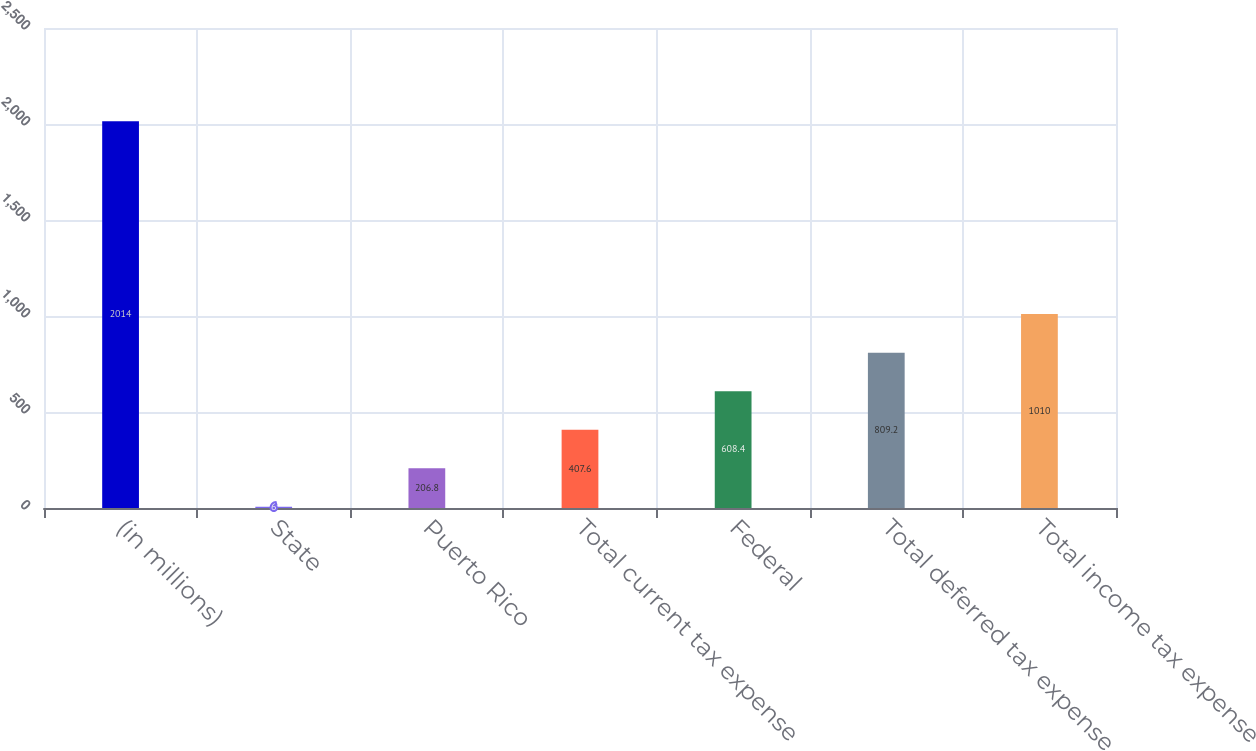Convert chart to OTSL. <chart><loc_0><loc_0><loc_500><loc_500><bar_chart><fcel>(in millions)<fcel>State<fcel>Puerto Rico<fcel>Total current tax expense<fcel>Federal<fcel>Total deferred tax expense<fcel>Total income tax expense<nl><fcel>2014<fcel>6<fcel>206.8<fcel>407.6<fcel>608.4<fcel>809.2<fcel>1010<nl></chart> 